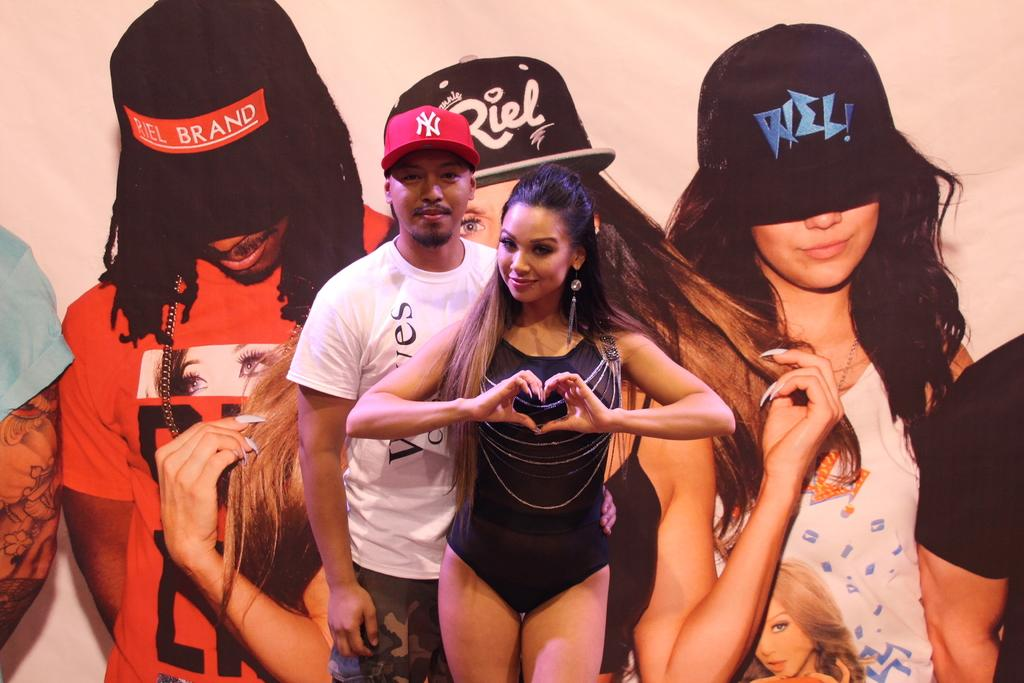<image>
Describe the image concisely. two people stand in front of a poster with word BRAND on it 